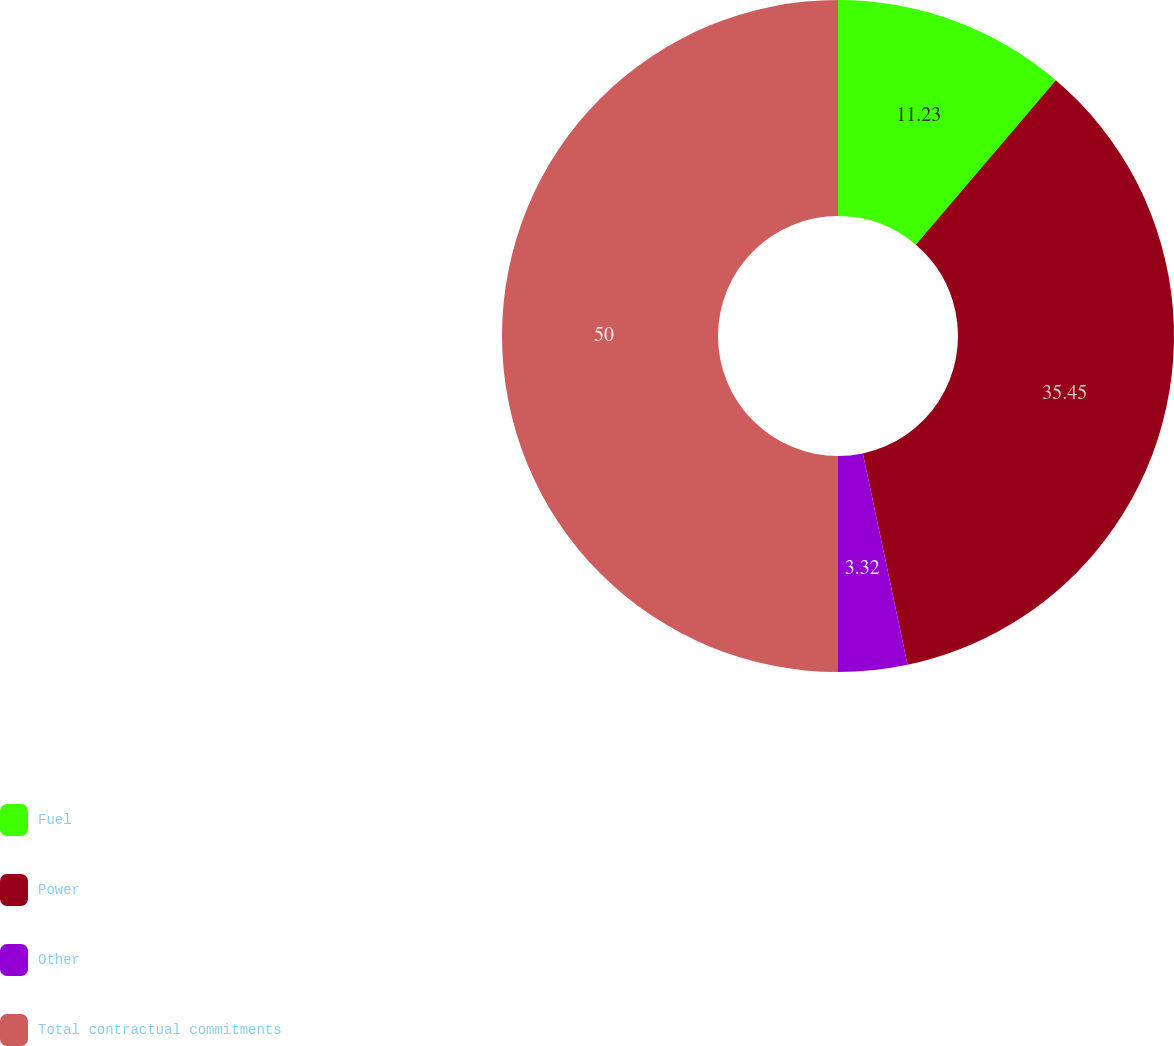Convert chart. <chart><loc_0><loc_0><loc_500><loc_500><pie_chart><fcel>Fuel<fcel>Power<fcel>Other<fcel>Total contractual commitments<nl><fcel>11.23%<fcel>35.45%<fcel>3.32%<fcel>50.0%<nl></chart> 